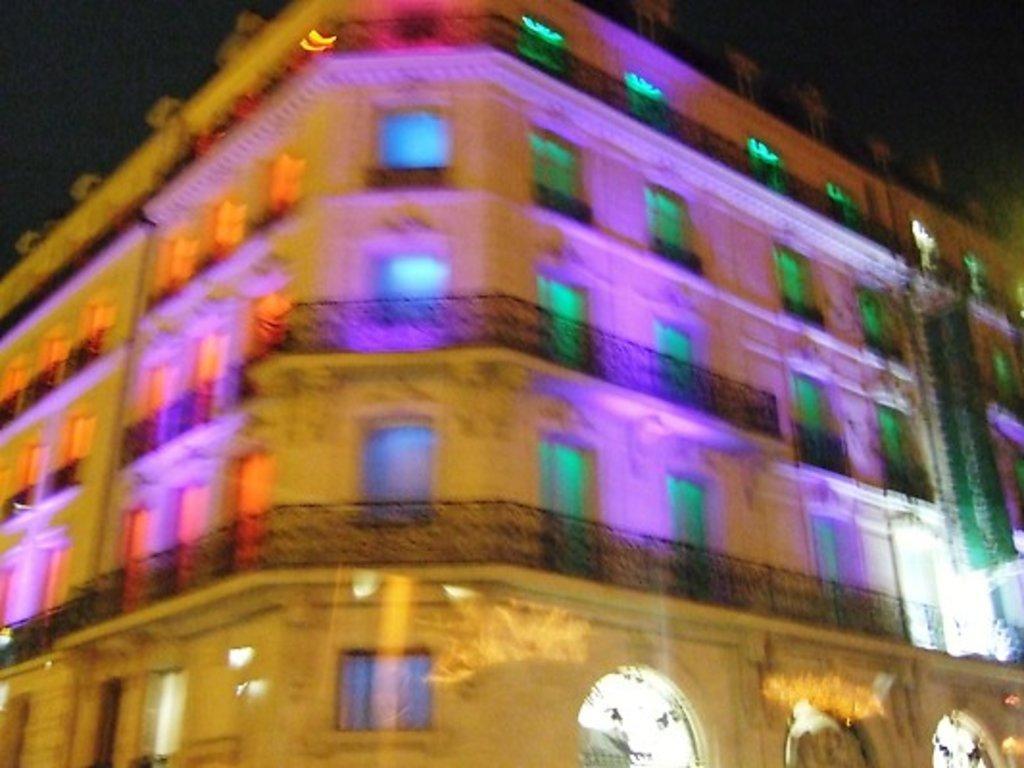How would you summarize this image in a sentence or two? In this image I can see a building, doors, windows and the sky. This image is taken may be during night. 